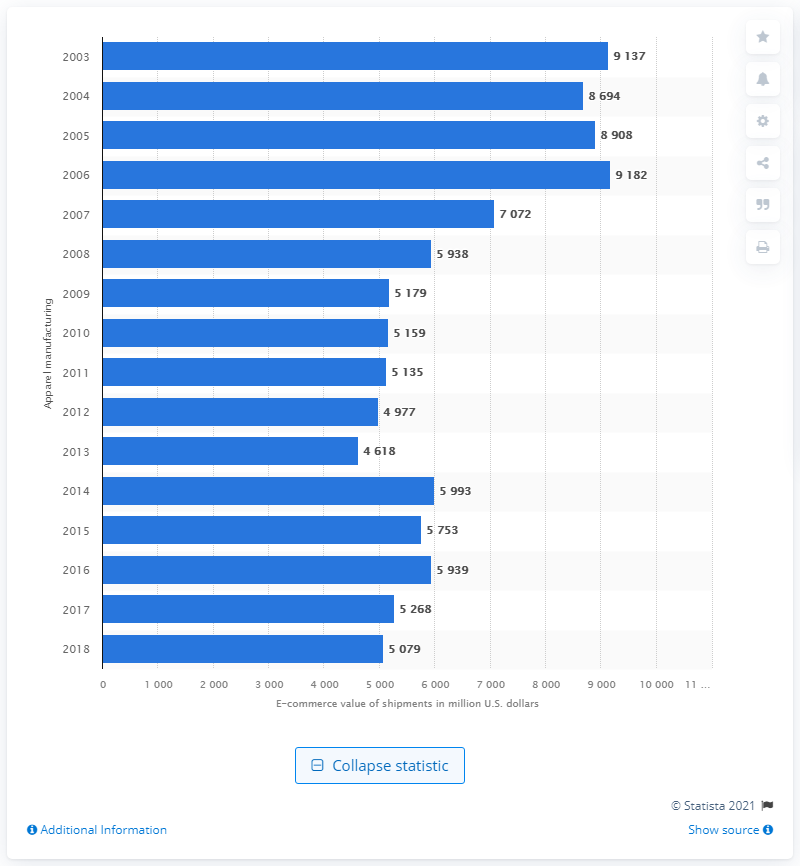Highlight a few significant elements in this photo. In the previous measured period, the B2B e-commerce value of apparel manufacturing shipments was $52,688. The B2B e-commerce value of apparel manufacturing shipments in the United States in 2018 was approximately $51,350. 